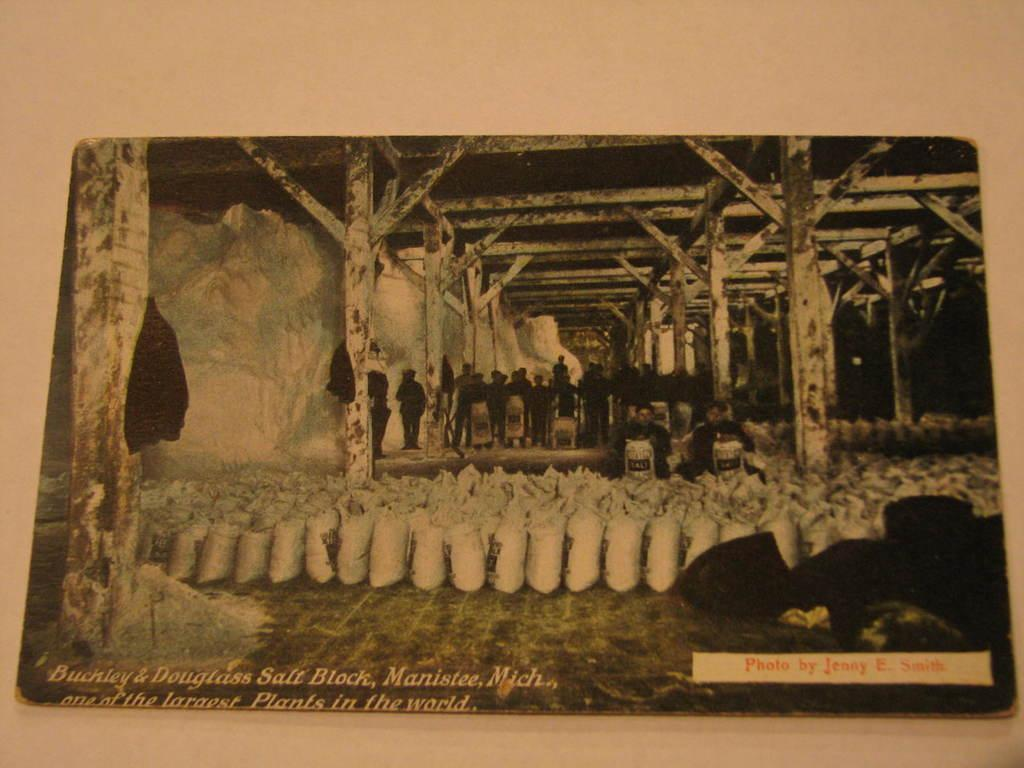What object is present in the image that typically holds a photograph? There is a photo frame in the image. What can be seen in the background of the photo frame? There are people standing in the backdrop of the photo frame. What items are placed on the floor in the image? There are bags placed on the floor in the image. What information is provided on the bags? The bags have a name printed on them. What type of canvas is being used for reading in the image? There is no canvas or reading activity present in the image. What type of army is depicted in the image? There is no army or military-related subject in the image. 